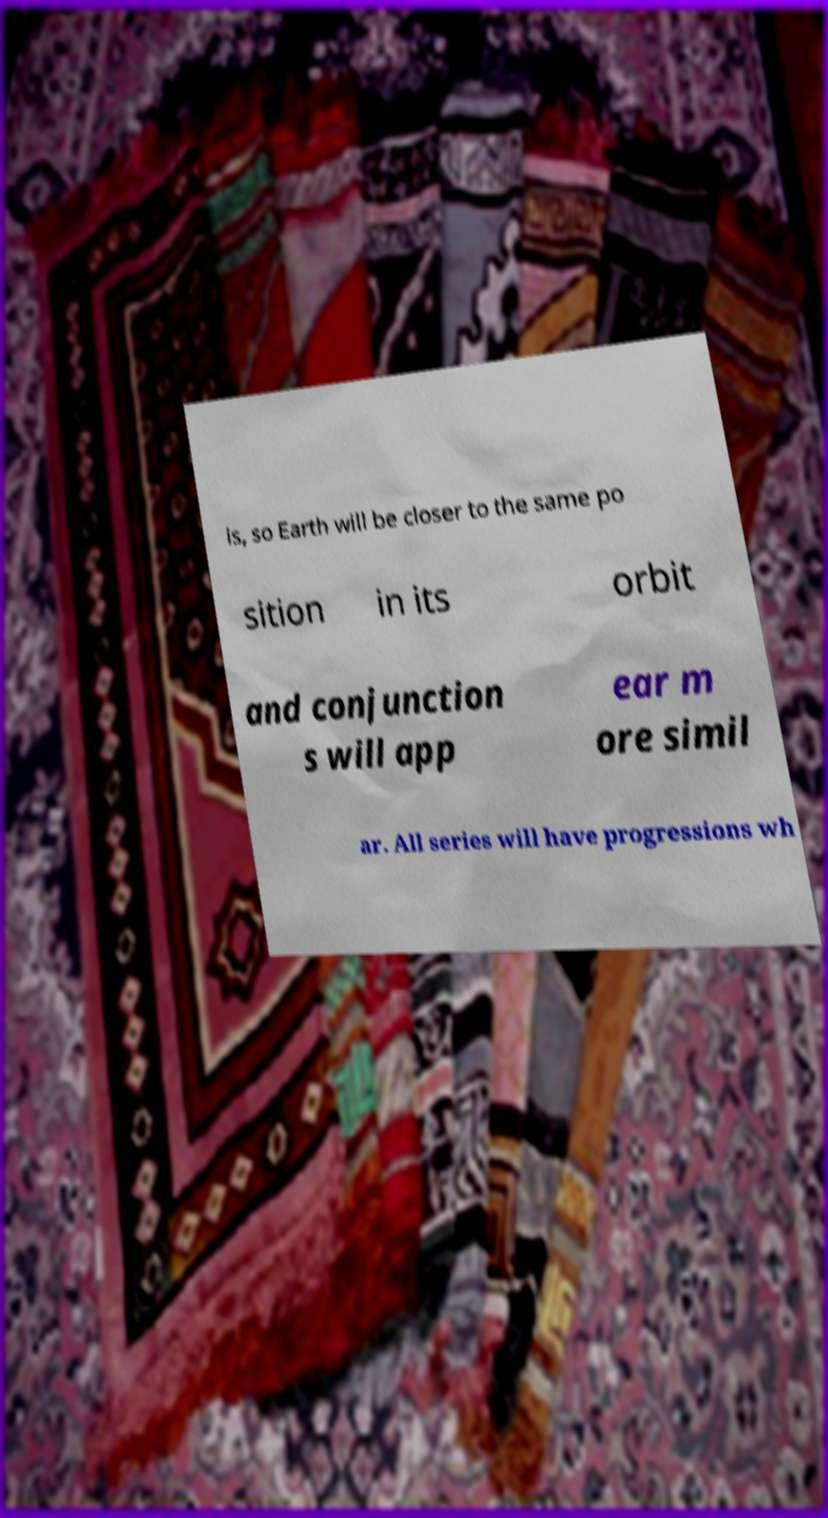Can you read and provide the text displayed in the image?This photo seems to have some interesting text. Can you extract and type it out for me? is, so Earth will be closer to the same po sition in its orbit and conjunction s will app ear m ore simil ar. All series will have progressions wh 